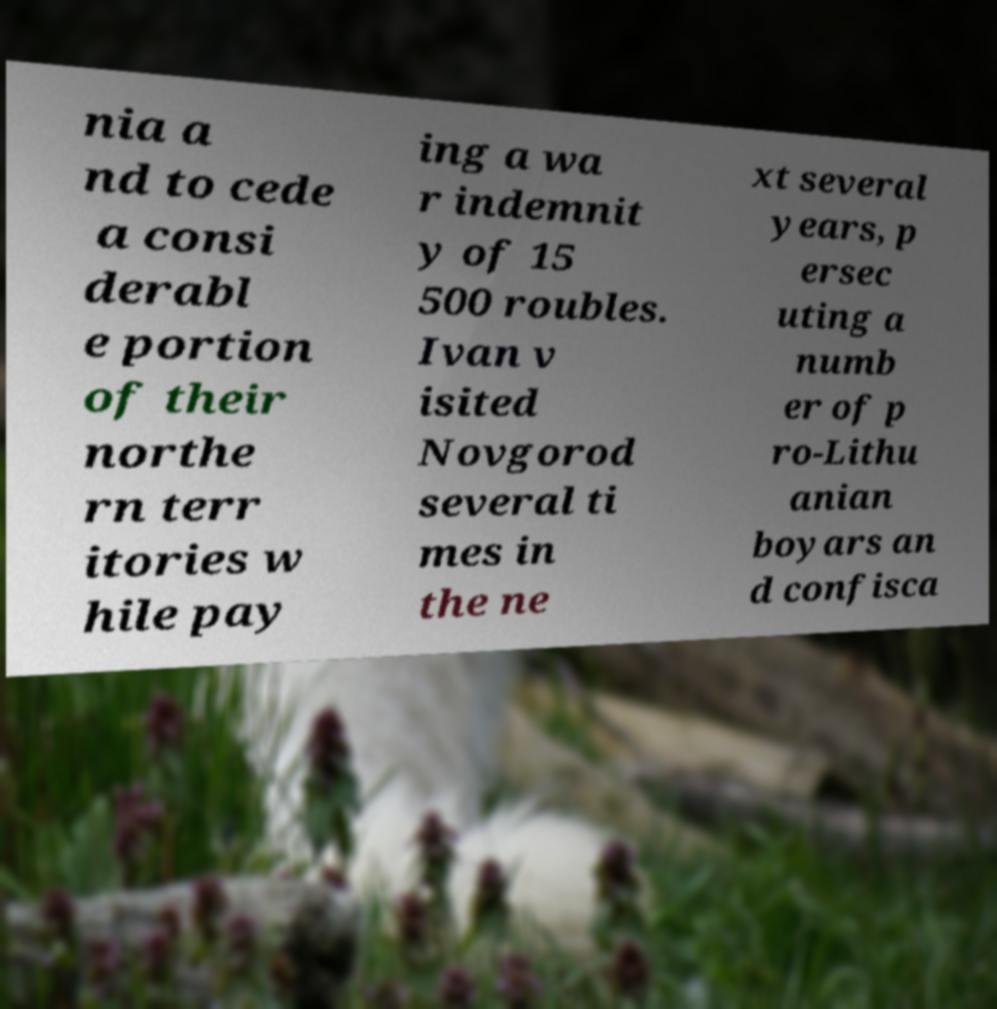Please read and relay the text visible in this image. What does it say? nia a nd to cede a consi derabl e portion of their northe rn terr itories w hile pay ing a wa r indemnit y of 15 500 roubles. Ivan v isited Novgorod several ti mes in the ne xt several years, p ersec uting a numb er of p ro-Lithu anian boyars an d confisca 